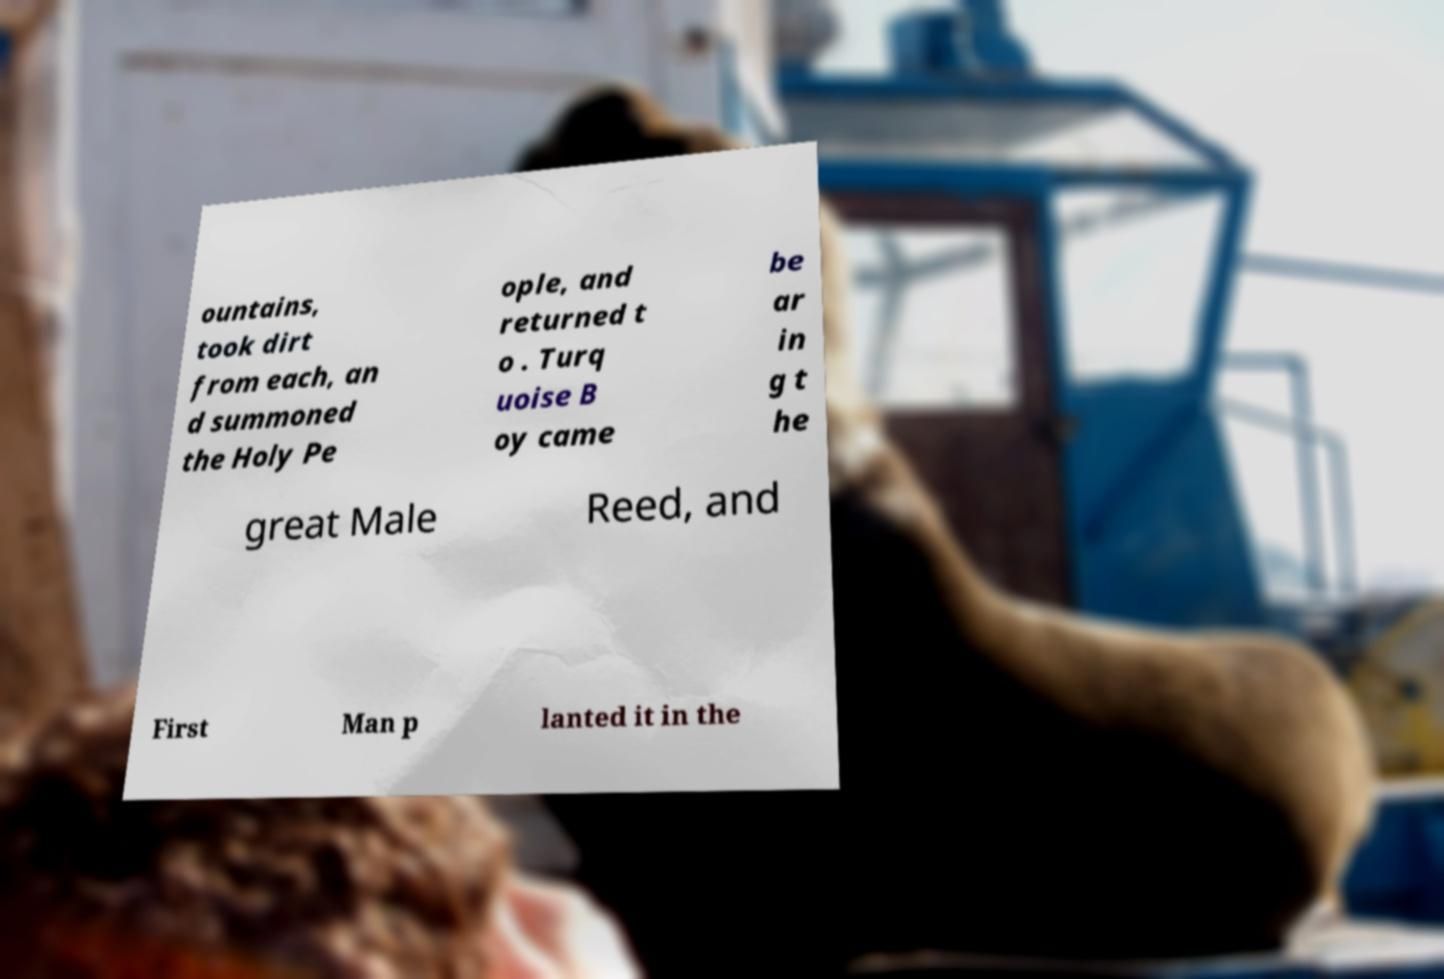Can you accurately transcribe the text from the provided image for me? ountains, took dirt from each, an d summoned the Holy Pe ople, and returned t o . Turq uoise B oy came be ar in g t he great Male Reed, and First Man p lanted it in the 